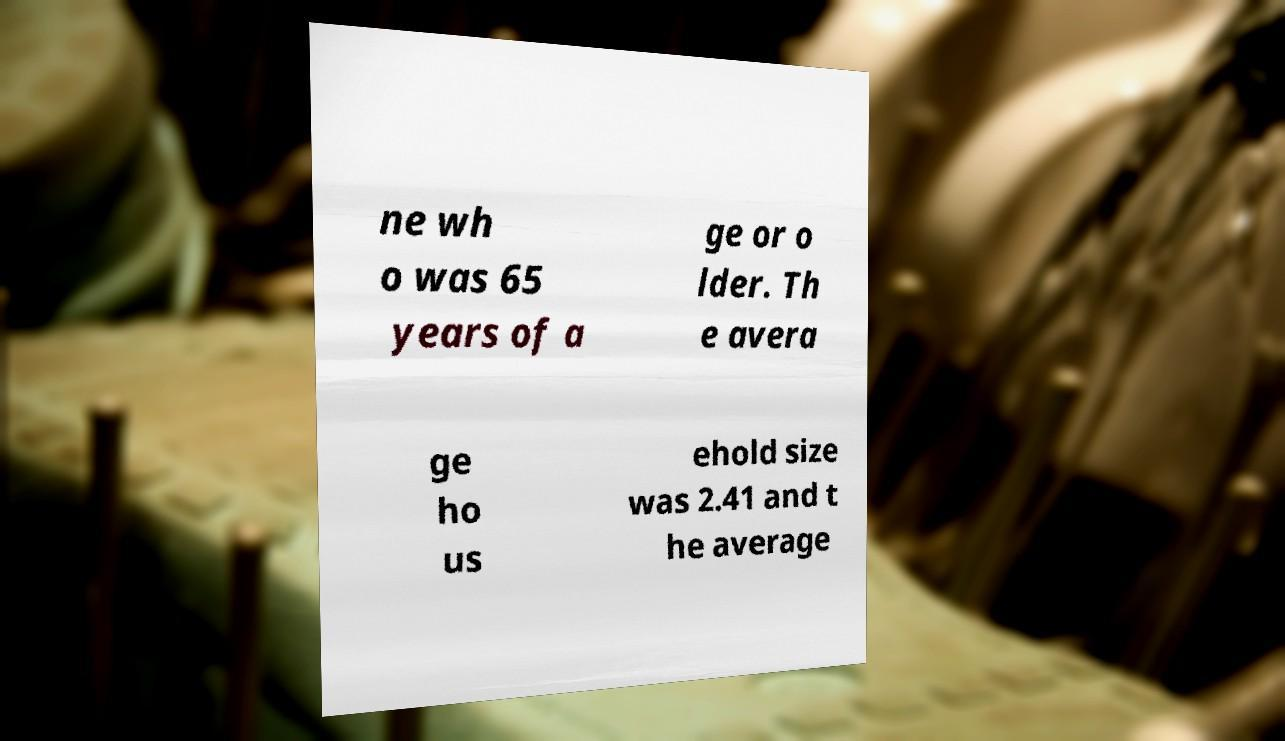Can you accurately transcribe the text from the provided image for me? ne wh o was 65 years of a ge or o lder. Th e avera ge ho us ehold size was 2.41 and t he average 